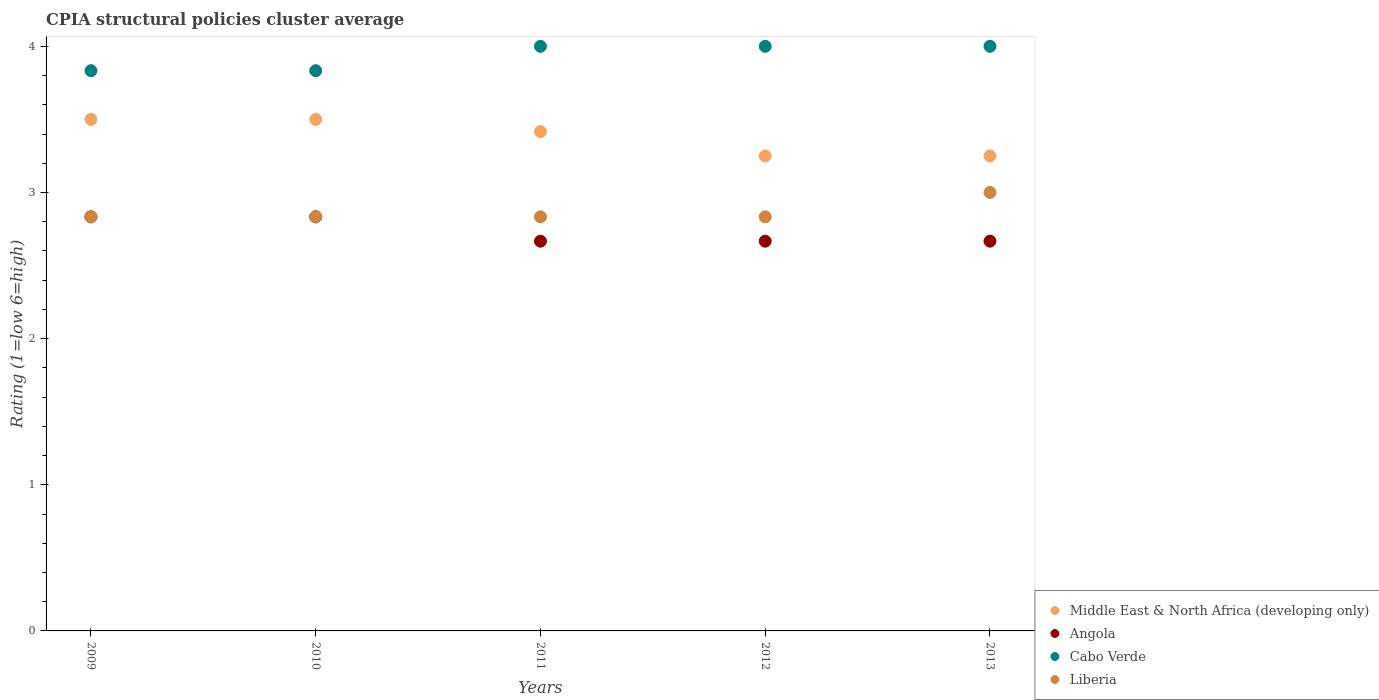How many different coloured dotlines are there?
Provide a short and direct response. 4. Is the number of dotlines equal to the number of legend labels?
Ensure brevity in your answer.  Yes. Across all years, what is the minimum CPIA rating in Cabo Verde?
Your answer should be very brief. 3.83. What is the total CPIA rating in Middle East & North Africa (developing only) in the graph?
Offer a very short reply. 16.92. What is the difference between the CPIA rating in Angola in 2009 and that in 2010?
Give a very brief answer. 0. What is the difference between the CPIA rating in Middle East & North Africa (developing only) in 2011 and the CPIA rating in Liberia in 2010?
Provide a succinct answer. 0.58. What is the average CPIA rating in Cabo Verde per year?
Offer a very short reply. 3.93. In the year 2009, what is the difference between the CPIA rating in Middle East & North Africa (developing only) and CPIA rating in Liberia?
Keep it short and to the point. 0.67. What is the ratio of the CPIA rating in Middle East & North Africa (developing only) in 2009 to that in 2010?
Keep it short and to the point. 1. Is the CPIA rating in Liberia in 2010 less than that in 2012?
Keep it short and to the point. No. Is the difference between the CPIA rating in Middle East & North Africa (developing only) in 2010 and 2011 greater than the difference between the CPIA rating in Liberia in 2010 and 2011?
Your answer should be compact. Yes. What is the difference between the highest and the second highest CPIA rating in Middle East & North Africa (developing only)?
Provide a short and direct response. 0. What is the difference between the highest and the lowest CPIA rating in Angola?
Give a very brief answer. 0.17. Is the sum of the CPIA rating in Middle East & North Africa (developing only) in 2009 and 2013 greater than the maximum CPIA rating in Liberia across all years?
Your response must be concise. Yes. Is it the case that in every year, the sum of the CPIA rating in Liberia and CPIA rating in Middle East & North Africa (developing only)  is greater than the CPIA rating in Cabo Verde?
Ensure brevity in your answer.  Yes. Does the CPIA rating in Cabo Verde monotonically increase over the years?
Your response must be concise. No. Is the CPIA rating in Liberia strictly less than the CPIA rating in Angola over the years?
Make the answer very short. No. How many dotlines are there?
Ensure brevity in your answer.  4. How many years are there in the graph?
Offer a terse response. 5. What is the difference between two consecutive major ticks on the Y-axis?
Your answer should be compact. 1. How are the legend labels stacked?
Your answer should be compact. Vertical. What is the title of the graph?
Ensure brevity in your answer.  CPIA structural policies cluster average. What is the label or title of the Y-axis?
Keep it short and to the point. Rating (1=low 6=high). What is the Rating (1=low 6=high) in Middle East & North Africa (developing only) in 2009?
Your answer should be very brief. 3.5. What is the Rating (1=low 6=high) of Angola in 2009?
Your answer should be compact. 2.83. What is the Rating (1=low 6=high) of Cabo Verde in 2009?
Make the answer very short. 3.83. What is the Rating (1=low 6=high) in Liberia in 2009?
Give a very brief answer. 2.83. What is the Rating (1=low 6=high) of Middle East & North Africa (developing only) in 2010?
Make the answer very short. 3.5. What is the Rating (1=low 6=high) in Angola in 2010?
Ensure brevity in your answer.  2.83. What is the Rating (1=low 6=high) of Cabo Verde in 2010?
Keep it short and to the point. 3.83. What is the Rating (1=low 6=high) of Liberia in 2010?
Your answer should be very brief. 2.83. What is the Rating (1=low 6=high) in Middle East & North Africa (developing only) in 2011?
Offer a very short reply. 3.42. What is the Rating (1=low 6=high) in Angola in 2011?
Ensure brevity in your answer.  2.67. What is the Rating (1=low 6=high) in Cabo Verde in 2011?
Offer a very short reply. 4. What is the Rating (1=low 6=high) in Liberia in 2011?
Provide a succinct answer. 2.83. What is the Rating (1=low 6=high) in Angola in 2012?
Give a very brief answer. 2.67. What is the Rating (1=low 6=high) of Liberia in 2012?
Provide a short and direct response. 2.83. What is the Rating (1=low 6=high) in Middle East & North Africa (developing only) in 2013?
Offer a very short reply. 3.25. What is the Rating (1=low 6=high) in Angola in 2013?
Ensure brevity in your answer.  2.67. What is the Rating (1=low 6=high) of Cabo Verde in 2013?
Offer a terse response. 4. What is the Rating (1=low 6=high) of Liberia in 2013?
Give a very brief answer. 3. Across all years, what is the maximum Rating (1=low 6=high) of Angola?
Provide a succinct answer. 2.83. Across all years, what is the maximum Rating (1=low 6=high) of Liberia?
Make the answer very short. 3. Across all years, what is the minimum Rating (1=low 6=high) of Angola?
Give a very brief answer. 2.67. Across all years, what is the minimum Rating (1=low 6=high) in Cabo Verde?
Your answer should be very brief. 3.83. Across all years, what is the minimum Rating (1=low 6=high) of Liberia?
Keep it short and to the point. 2.83. What is the total Rating (1=low 6=high) in Middle East & North Africa (developing only) in the graph?
Your answer should be compact. 16.92. What is the total Rating (1=low 6=high) in Angola in the graph?
Provide a short and direct response. 13.67. What is the total Rating (1=low 6=high) of Cabo Verde in the graph?
Provide a succinct answer. 19.67. What is the total Rating (1=low 6=high) of Liberia in the graph?
Make the answer very short. 14.33. What is the difference between the Rating (1=low 6=high) in Middle East & North Africa (developing only) in 2009 and that in 2010?
Your answer should be very brief. 0. What is the difference between the Rating (1=low 6=high) of Middle East & North Africa (developing only) in 2009 and that in 2011?
Keep it short and to the point. 0.08. What is the difference between the Rating (1=low 6=high) in Cabo Verde in 2009 and that in 2011?
Keep it short and to the point. -0.17. What is the difference between the Rating (1=low 6=high) of Liberia in 2009 and that in 2011?
Your response must be concise. 0. What is the difference between the Rating (1=low 6=high) of Middle East & North Africa (developing only) in 2009 and that in 2012?
Offer a terse response. 0.25. What is the difference between the Rating (1=low 6=high) of Cabo Verde in 2009 and that in 2012?
Offer a very short reply. -0.17. What is the difference between the Rating (1=low 6=high) in Middle East & North Africa (developing only) in 2009 and that in 2013?
Keep it short and to the point. 0.25. What is the difference between the Rating (1=low 6=high) of Angola in 2009 and that in 2013?
Your answer should be very brief. 0.17. What is the difference between the Rating (1=low 6=high) of Liberia in 2009 and that in 2013?
Ensure brevity in your answer.  -0.17. What is the difference between the Rating (1=low 6=high) of Middle East & North Africa (developing only) in 2010 and that in 2011?
Ensure brevity in your answer.  0.08. What is the difference between the Rating (1=low 6=high) of Liberia in 2010 and that in 2011?
Give a very brief answer. 0. What is the difference between the Rating (1=low 6=high) of Middle East & North Africa (developing only) in 2010 and that in 2012?
Your answer should be very brief. 0.25. What is the difference between the Rating (1=low 6=high) of Angola in 2010 and that in 2012?
Offer a very short reply. 0.17. What is the difference between the Rating (1=low 6=high) in Cabo Verde in 2010 and that in 2012?
Keep it short and to the point. -0.17. What is the difference between the Rating (1=low 6=high) of Middle East & North Africa (developing only) in 2010 and that in 2013?
Your answer should be very brief. 0.25. What is the difference between the Rating (1=low 6=high) in Angola in 2010 and that in 2013?
Offer a very short reply. 0.17. What is the difference between the Rating (1=low 6=high) of Cabo Verde in 2010 and that in 2013?
Provide a succinct answer. -0.17. What is the difference between the Rating (1=low 6=high) of Liberia in 2010 and that in 2013?
Your answer should be very brief. -0.17. What is the difference between the Rating (1=low 6=high) of Middle East & North Africa (developing only) in 2011 and that in 2012?
Offer a very short reply. 0.17. What is the difference between the Rating (1=low 6=high) in Angola in 2011 and that in 2012?
Your answer should be compact. 0. What is the difference between the Rating (1=low 6=high) of Cabo Verde in 2011 and that in 2012?
Give a very brief answer. 0. What is the difference between the Rating (1=low 6=high) of Angola in 2011 and that in 2013?
Offer a very short reply. 0. What is the difference between the Rating (1=low 6=high) of Cabo Verde in 2011 and that in 2013?
Provide a short and direct response. 0. What is the difference between the Rating (1=low 6=high) of Liberia in 2011 and that in 2013?
Your answer should be very brief. -0.17. What is the difference between the Rating (1=low 6=high) of Angola in 2012 and that in 2013?
Ensure brevity in your answer.  0. What is the difference between the Rating (1=low 6=high) in Liberia in 2012 and that in 2013?
Keep it short and to the point. -0.17. What is the difference between the Rating (1=low 6=high) in Middle East & North Africa (developing only) in 2009 and the Rating (1=low 6=high) in Cabo Verde in 2010?
Give a very brief answer. -0.33. What is the difference between the Rating (1=low 6=high) in Angola in 2009 and the Rating (1=low 6=high) in Cabo Verde in 2010?
Give a very brief answer. -1. What is the difference between the Rating (1=low 6=high) in Middle East & North Africa (developing only) in 2009 and the Rating (1=low 6=high) in Liberia in 2011?
Ensure brevity in your answer.  0.67. What is the difference between the Rating (1=low 6=high) in Angola in 2009 and the Rating (1=low 6=high) in Cabo Verde in 2011?
Provide a short and direct response. -1.17. What is the difference between the Rating (1=low 6=high) of Angola in 2009 and the Rating (1=low 6=high) of Liberia in 2011?
Give a very brief answer. 0. What is the difference between the Rating (1=low 6=high) of Middle East & North Africa (developing only) in 2009 and the Rating (1=low 6=high) of Liberia in 2012?
Your answer should be very brief. 0.67. What is the difference between the Rating (1=low 6=high) of Angola in 2009 and the Rating (1=low 6=high) of Cabo Verde in 2012?
Ensure brevity in your answer.  -1.17. What is the difference between the Rating (1=low 6=high) in Cabo Verde in 2009 and the Rating (1=low 6=high) in Liberia in 2012?
Your answer should be compact. 1. What is the difference between the Rating (1=low 6=high) in Angola in 2009 and the Rating (1=low 6=high) in Cabo Verde in 2013?
Offer a terse response. -1.17. What is the difference between the Rating (1=low 6=high) in Middle East & North Africa (developing only) in 2010 and the Rating (1=low 6=high) in Angola in 2011?
Ensure brevity in your answer.  0.83. What is the difference between the Rating (1=low 6=high) in Middle East & North Africa (developing only) in 2010 and the Rating (1=low 6=high) in Cabo Verde in 2011?
Offer a terse response. -0.5. What is the difference between the Rating (1=low 6=high) of Middle East & North Africa (developing only) in 2010 and the Rating (1=low 6=high) of Liberia in 2011?
Offer a very short reply. 0.67. What is the difference between the Rating (1=low 6=high) in Angola in 2010 and the Rating (1=low 6=high) in Cabo Verde in 2011?
Offer a very short reply. -1.17. What is the difference between the Rating (1=low 6=high) in Angola in 2010 and the Rating (1=low 6=high) in Liberia in 2011?
Offer a terse response. 0. What is the difference between the Rating (1=low 6=high) in Cabo Verde in 2010 and the Rating (1=low 6=high) in Liberia in 2011?
Ensure brevity in your answer.  1. What is the difference between the Rating (1=low 6=high) of Middle East & North Africa (developing only) in 2010 and the Rating (1=low 6=high) of Liberia in 2012?
Make the answer very short. 0.67. What is the difference between the Rating (1=low 6=high) of Angola in 2010 and the Rating (1=low 6=high) of Cabo Verde in 2012?
Your answer should be very brief. -1.17. What is the difference between the Rating (1=low 6=high) of Cabo Verde in 2010 and the Rating (1=low 6=high) of Liberia in 2012?
Your response must be concise. 1. What is the difference between the Rating (1=low 6=high) in Middle East & North Africa (developing only) in 2010 and the Rating (1=low 6=high) in Angola in 2013?
Your response must be concise. 0.83. What is the difference between the Rating (1=low 6=high) in Middle East & North Africa (developing only) in 2010 and the Rating (1=low 6=high) in Liberia in 2013?
Give a very brief answer. 0.5. What is the difference between the Rating (1=low 6=high) of Angola in 2010 and the Rating (1=low 6=high) of Cabo Verde in 2013?
Ensure brevity in your answer.  -1.17. What is the difference between the Rating (1=low 6=high) of Angola in 2010 and the Rating (1=low 6=high) of Liberia in 2013?
Your response must be concise. -0.17. What is the difference between the Rating (1=low 6=high) in Cabo Verde in 2010 and the Rating (1=low 6=high) in Liberia in 2013?
Keep it short and to the point. 0.83. What is the difference between the Rating (1=low 6=high) in Middle East & North Africa (developing only) in 2011 and the Rating (1=low 6=high) in Cabo Verde in 2012?
Your response must be concise. -0.58. What is the difference between the Rating (1=low 6=high) of Middle East & North Africa (developing only) in 2011 and the Rating (1=low 6=high) of Liberia in 2012?
Offer a very short reply. 0.58. What is the difference between the Rating (1=low 6=high) in Angola in 2011 and the Rating (1=low 6=high) in Cabo Verde in 2012?
Give a very brief answer. -1.33. What is the difference between the Rating (1=low 6=high) in Cabo Verde in 2011 and the Rating (1=low 6=high) in Liberia in 2012?
Keep it short and to the point. 1.17. What is the difference between the Rating (1=low 6=high) of Middle East & North Africa (developing only) in 2011 and the Rating (1=low 6=high) of Angola in 2013?
Ensure brevity in your answer.  0.75. What is the difference between the Rating (1=low 6=high) of Middle East & North Africa (developing only) in 2011 and the Rating (1=low 6=high) of Cabo Verde in 2013?
Your response must be concise. -0.58. What is the difference between the Rating (1=low 6=high) in Middle East & North Africa (developing only) in 2011 and the Rating (1=low 6=high) in Liberia in 2013?
Ensure brevity in your answer.  0.42. What is the difference between the Rating (1=low 6=high) in Angola in 2011 and the Rating (1=low 6=high) in Cabo Verde in 2013?
Your answer should be very brief. -1.33. What is the difference between the Rating (1=low 6=high) of Middle East & North Africa (developing only) in 2012 and the Rating (1=low 6=high) of Angola in 2013?
Your answer should be compact. 0.58. What is the difference between the Rating (1=low 6=high) of Middle East & North Africa (developing only) in 2012 and the Rating (1=low 6=high) of Cabo Verde in 2013?
Offer a terse response. -0.75. What is the difference between the Rating (1=low 6=high) of Angola in 2012 and the Rating (1=low 6=high) of Cabo Verde in 2013?
Offer a very short reply. -1.33. What is the average Rating (1=low 6=high) in Middle East & North Africa (developing only) per year?
Give a very brief answer. 3.38. What is the average Rating (1=low 6=high) in Angola per year?
Provide a short and direct response. 2.73. What is the average Rating (1=low 6=high) of Cabo Verde per year?
Ensure brevity in your answer.  3.93. What is the average Rating (1=low 6=high) in Liberia per year?
Your response must be concise. 2.87. In the year 2009, what is the difference between the Rating (1=low 6=high) in Middle East & North Africa (developing only) and Rating (1=low 6=high) in Cabo Verde?
Your answer should be very brief. -0.33. In the year 2009, what is the difference between the Rating (1=low 6=high) of Angola and Rating (1=low 6=high) of Liberia?
Give a very brief answer. 0. In the year 2009, what is the difference between the Rating (1=low 6=high) of Cabo Verde and Rating (1=low 6=high) of Liberia?
Offer a terse response. 1. In the year 2010, what is the difference between the Rating (1=low 6=high) of Middle East & North Africa (developing only) and Rating (1=low 6=high) of Cabo Verde?
Make the answer very short. -0.33. In the year 2010, what is the difference between the Rating (1=low 6=high) of Middle East & North Africa (developing only) and Rating (1=low 6=high) of Liberia?
Your answer should be very brief. 0.67. In the year 2010, what is the difference between the Rating (1=low 6=high) in Cabo Verde and Rating (1=low 6=high) in Liberia?
Your response must be concise. 1. In the year 2011, what is the difference between the Rating (1=low 6=high) of Middle East & North Africa (developing only) and Rating (1=low 6=high) of Cabo Verde?
Provide a succinct answer. -0.58. In the year 2011, what is the difference between the Rating (1=low 6=high) in Middle East & North Africa (developing only) and Rating (1=low 6=high) in Liberia?
Your answer should be compact. 0.58. In the year 2011, what is the difference between the Rating (1=low 6=high) in Angola and Rating (1=low 6=high) in Cabo Verde?
Give a very brief answer. -1.33. In the year 2011, what is the difference between the Rating (1=low 6=high) of Cabo Verde and Rating (1=low 6=high) of Liberia?
Provide a succinct answer. 1.17. In the year 2012, what is the difference between the Rating (1=low 6=high) of Middle East & North Africa (developing only) and Rating (1=low 6=high) of Angola?
Make the answer very short. 0.58. In the year 2012, what is the difference between the Rating (1=low 6=high) of Middle East & North Africa (developing only) and Rating (1=low 6=high) of Cabo Verde?
Your answer should be very brief. -0.75. In the year 2012, what is the difference between the Rating (1=low 6=high) of Middle East & North Africa (developing only) and Rating (1=low 6=high) of Liberia?
Your response must be concise. 0.42. In the year 2012, what is the difference between the Rating (1=low 6=high) in Angola and Rating (1=low 6=high) in Cabo Verde?
Keep it short and to the point. -1.33. In the year 2012, what is the difference between the Rating (1=low 6=high) of Cabo Verde and Rating (1=low 6=high) of Liberia?
Your answer should be very brief. 1.17. In the year 2013, what is the difference between the Rating (1=low 6=high) of Middle East & North Africa (developing only) and Rating (1=low 6=high) of Angola?
Provide a short and direct response. 0.58. In the year 2013, what is the difference between the Rating (1=low 6=high) of Middle East & North Africa (developing only) and Rating (1=low 6=high) of Cabo Verde?
Provide a short and direct response. -0.75. In the year 2013, what is the difference between the Rating (1=low 6=high) in Angola and Rating (1=low 6=high) in Cabo Verde?
Your response must be concise. -1.33. In the year 2013, what is the difference between the Rating (1=low 6=high) in Angola and Rating (1=low 6=high) in Liberia?
Your answer should be compact. -0.33. What is the ratio of the Rating (1=low 6=high) in Middle East & North Africa (developing only) in 2009 to that in 2010?
Offer a very short reply. 1. What is the ratio of the Rating (1=low 6=high) in Middle East & North Africa (developing only) in 2009 to that in 2011?
Provide a short and direct response. 1.02. What is the ratio of the Rating (1=low 6=high) in Angola in 2009 to that in 2011?
Keep it short and to the point. 1.06. What is the ratio of the Rating (1=low 6=high) of Liberia in 2009 to that in 2011?
Provide a succinct answer. 1. What is the ratio of the Rating (1=low 6=high) of Middle East & North Africa (developing only) in 2009 to that in 2012?
Your answer should be very brief. 1.08. What is the ratio of the Rating (1=low 6=high) in Angola in 2009 to that in 2012?
Ensure brevity in your answer.  1.06. What is the ratio of the Rating (1=low 6=high) in Liberia in 2009 to that in 2012?
Ensure brevity in your answer.  1. What is the ratio of the Rating (1=low 6=high) in Middle East & North Africa (developing only) in 2009 to that in 2013?
Provide a succinct answer. 1.08. What is the ratio of the Rating (1=low 6=high) in Liberia in 2009 to that in 2013?
Your response must be concise. 0.94. What is the ratio of the Rating (1=low 6=high) of Middle East & North Africa (developing only) in 2010 to that in 2011?
Keep it short and to the point. 1.02. What is the ratio of the Rating (1=low 6=high) of Angola in 2010 to that in 2011?
Ensure brevity in your answer.  1.06. What is the ratio of the Rating (1=low 6=high) of Middle East & North Africa (developing only) in 2010 to that in 2012?
Make the answer very short. 1.08. What is the ratio of the Rating (1=low 6=high) in Middle East & North Africa (developing only) in 2010 to that in 2013?
Make the answer very short. 1.08. What is the ratio of the Rating (1=low 6=high) of Middle East & North Africa (developing only) in 2011 to that in 2012?
Your answer should be very brief. 1.05. What is the ratio of the Rating (1=low 6=high) in Angola in 2011 to that in 2012?
Your answer should be very brief. 1. What is the ratio of the Rating (1=low 6=high) in Cabo Verde in 2011 to that in 2012?
Keep it short and to the point. 1. What is the ratio of the Rating (1=low 6=high) in Liberia in 2011 to that in 2012?
Keep it short and to the point. 1. What is the ratio of the Rating (1=low 6=high) in Middle East & North Africa (developing only) in 2011 to that in 2013?
Your response must be concise. 1.05. What is the ratio of the Rating (1=low 6=high) of Angola in 2011 to that in 2013?
Make the answer very short. 1. What is the ratio of the Rating (1=low 6=high) in Cabo Verde in 2011 to that in 2013?
Provide a succinct answer. 1. What is the ratio of the Rating (1=low 6=high) in Liberia in 2011 to that in 2013?
Offer a very short reply. 0.94. What is the ratio of the Rating (1=low 6=high) in Angola in 2012 to that in 2013?
Give a very brief answer. 1. What is the ratio of the Rating (1=low 6=high) of Liberia in 2012 to that in 2013?
Your response must be concise. 0.94. What is the difference between the highest and the second highest Rating (1=low 6=high) in Middle East & North Africa (developing only)?
Make the answer very short. 0. What is the difference between the highest and the second highest Rating (1=low 6=high) in Angola?
Keep it short and to the point. 0. What is the difference between the highest and the second highest Rating (1=low 6=high) in Liberia?
Make the answer very short. 0.17. What is the difference between the highest and the lowest Rating (1=low 6=high) of Angola?
Your answer should be compact. 0.17. What is the difference between the highest and the lowest Rating (1=low 6=high) of Cabo Verde?
Provide a short and direct response. 0.17. 